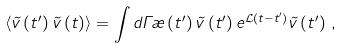<formula> <loc_0><loc_0><loc_500><loc_500>\left < \vec { v } \left ( t ^ { \prime } \right ) \vec { v } \left ( t \right ) \right > = \int d \Gamma \rho \left ( t ^ { \prime } \right ) \vec { v } \left ( t ^ { \prime } \right ) e ^ { { \mathcal { L } } \left ( t - t ^ { \prime } \right ) } \vec { v } \left ( t ^ { \prime } \right ) \, ,</formula> 